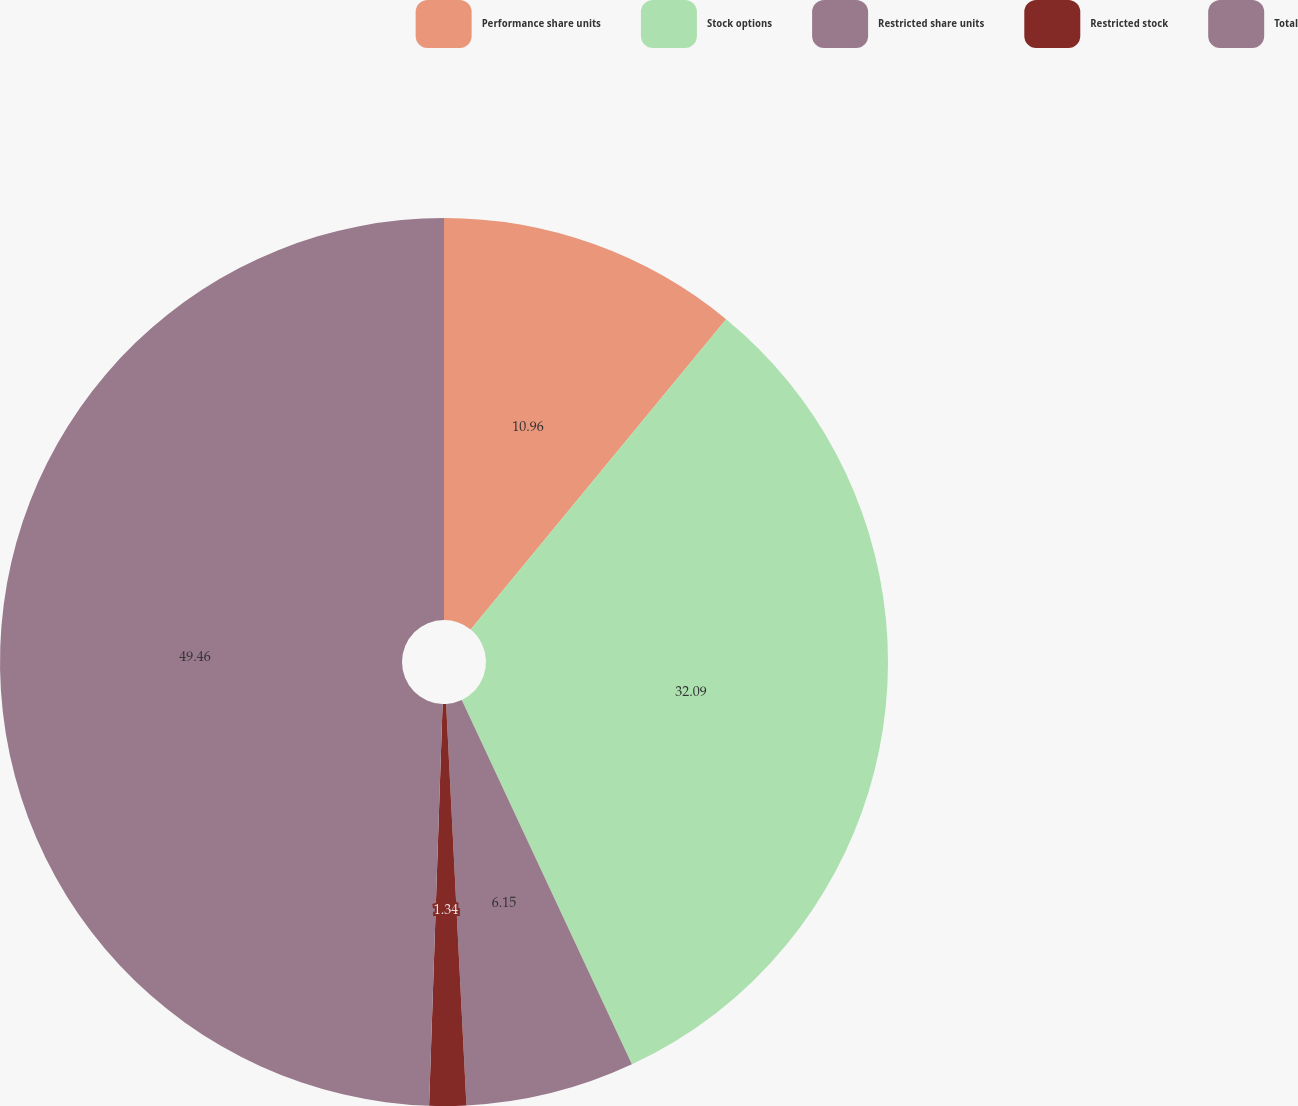<chart> <loc_0><loc_0><loc_500><loc_500><pie_chart><fcel>Performance share units<fcel>Stock options<fcel>Restricted share units<fcel>Restricted stock<fcel>Total<nl><fcel>10.96%<fcel>32.09%<fcel>6.15%<fcel>1.34%<fcel>49.47%<nl></chart> 